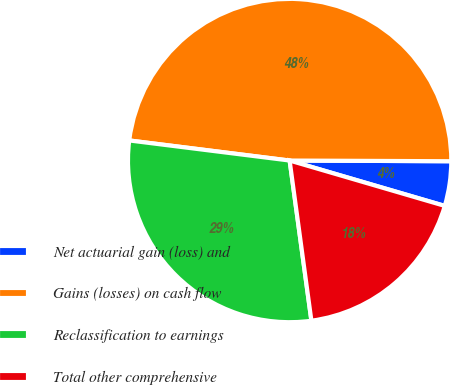<chart> <loc_0><loc_0><loc_500><loc_500><pie_chart><fcel>Net actuarial gain (loss) and<fcel>Gains (losses) on cash flow<fcel>Reclassification to earnings<fcel>Total other comprehensive<nl><fcel>4.46%<fcel>48.08%<fcel>29.13%<fcel>18.32%<nl></chart> 